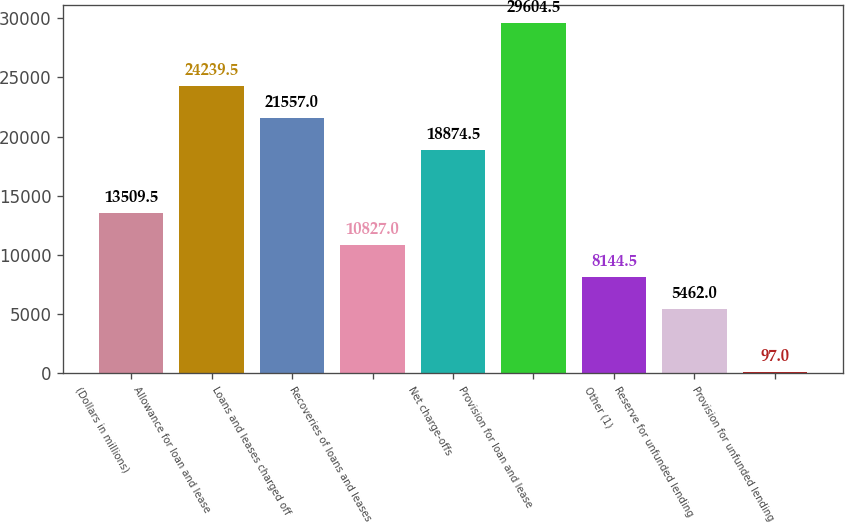<chart> <loc_0><loc_0><loc_500><loc_500><bar_chart><fcel>(Dollars in millions)<fcel>Allowance for loan and lease<fcel>Loans and leases charged off<fcel>Recoveries of loans and leases<fcel>Net charge-offs<fcel>Provision for loan and lease<fcel>Other (1)<fcel>Reserve for unfunded lending<fcel>Provision for unfunded lending<nl><fcel>13509.5<fcel>24239.5<fcel>21557<fcel>10827<fcel>18874.5<fcel>29604.5<fcel>8144.5<fcel>5462<fcel>97<nl></chart> 